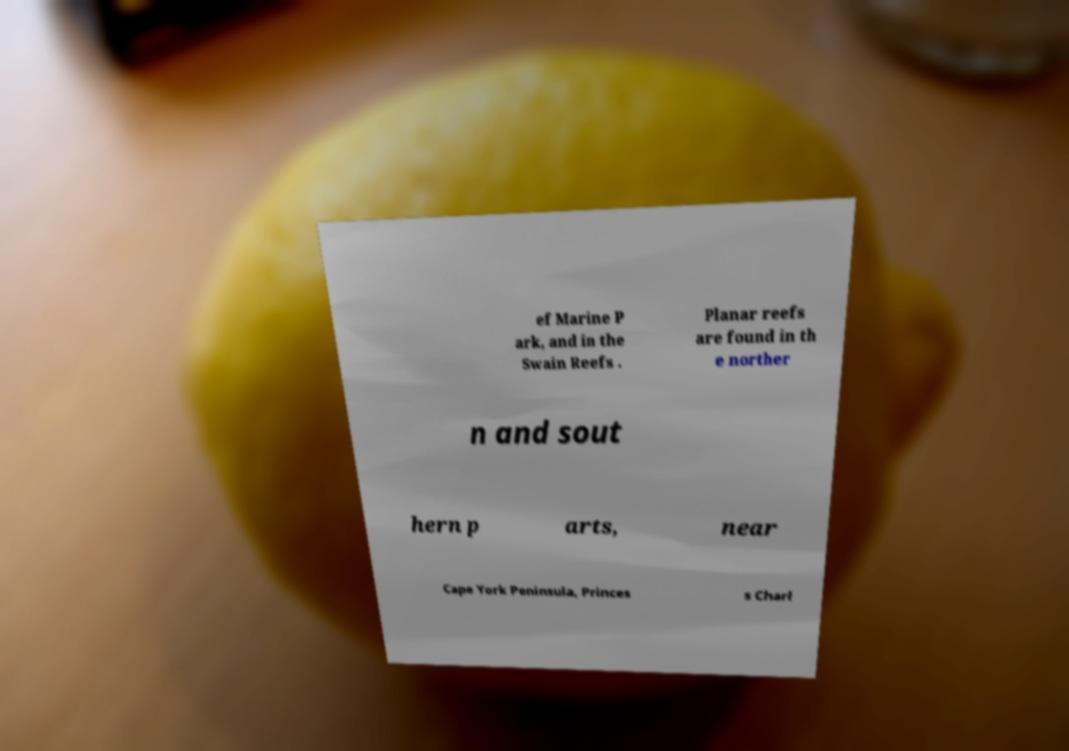Please identify and transcribe the text found in this image. ef Marine P ark, and in the Swain Reefs . Planar reefs are found in th e norther n and sout hern p arts, near Cape York Peninsula, Princes s Charl 